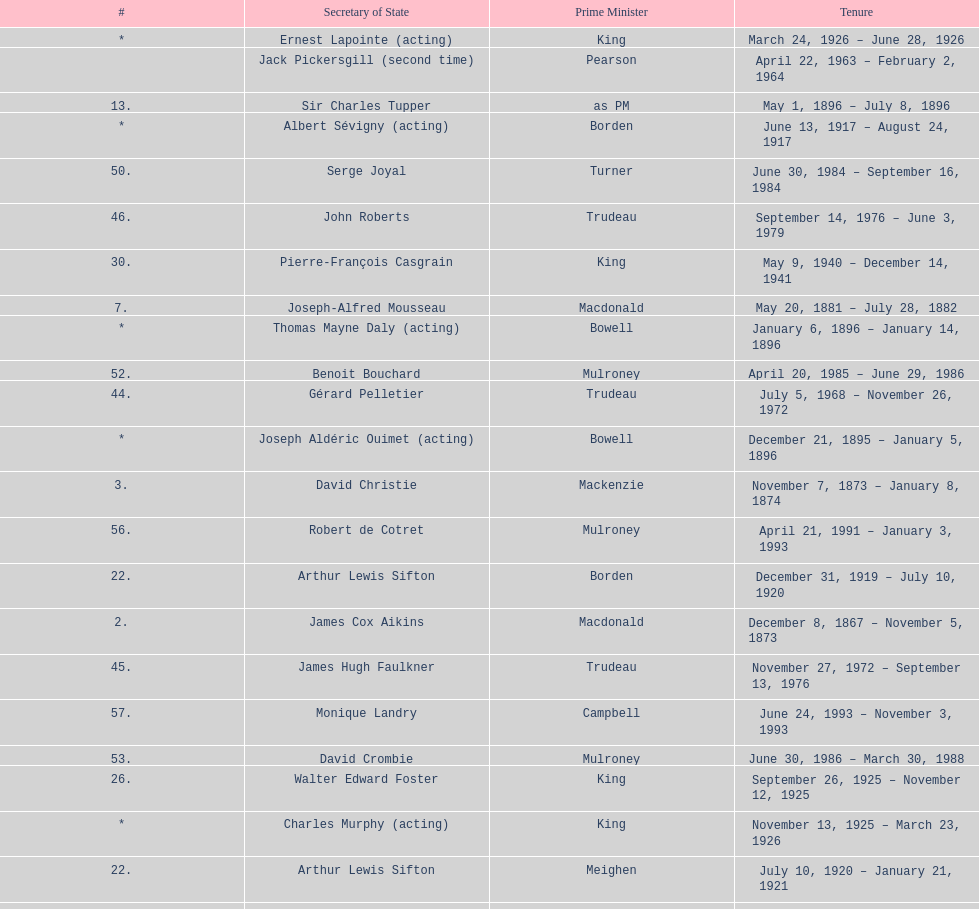How many secretaries of state had the last name bouchard? 2. 